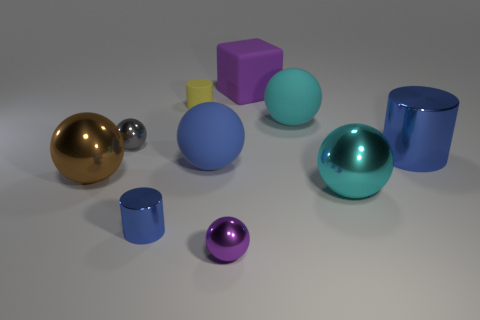Imagine these objects were part of a physics lesson, what could they demonstrate? These objects could be used to demonstrate several physics principles such as the effects of light on different surfaces, exemplifying specular and diffuse reflection. They could also be used to discuss surface area and volume relations across shapes, as well as basic concepts of geometry and spatial arrangement. 